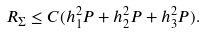<formula> <loc_0><loc_0><loc_500><loc_500>R _ { \Sigma } \leq C ( h _ { 1 } ^ { 2 } P + h _ { 2 } ^ { 2 } P + h _ { 3 } ^ { 2 } P ) .</formula> 